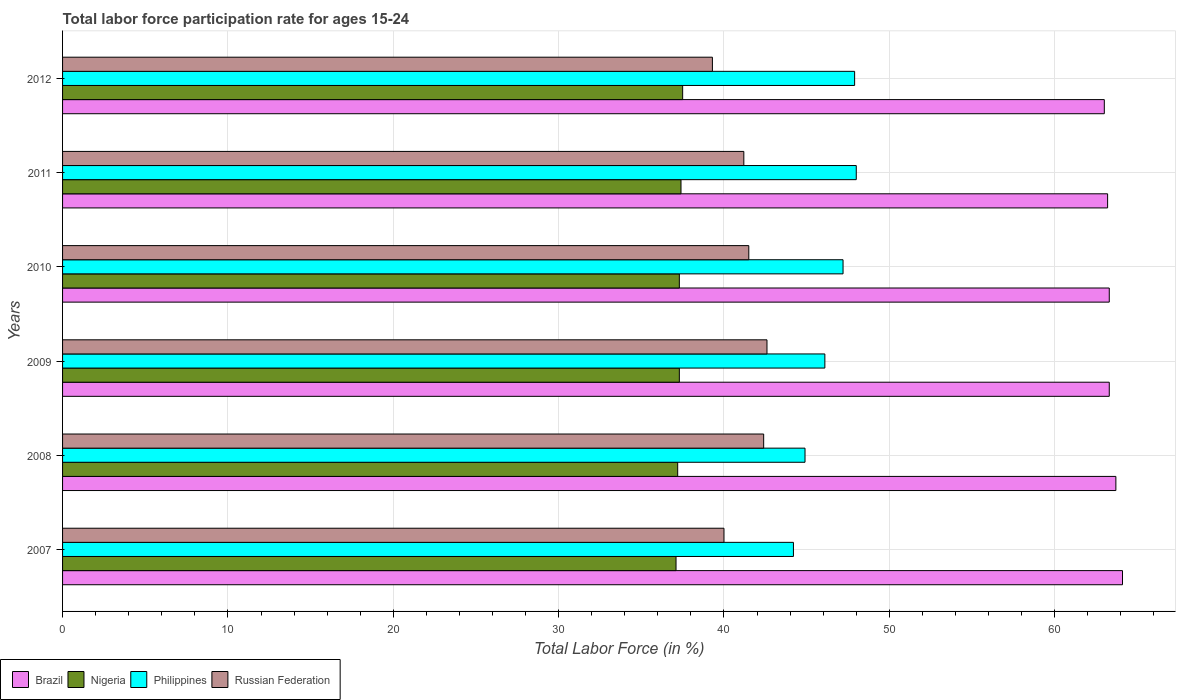How many different coloured bars are there?
Your answer should be compact. 4. How many groups of bars are there?
Your answer should be very brief. 6. Are the number of bars per tick equal to the number of legend labels?
Keep it short and to the point. Yes. Are the number of bars on each tick of the Y-axis equal?
Your response must be concise. Yes. What is the label of the 1st group of bars from the top?
Make the answer very short. 2012. In how many cases, is the number of bars for a given year not equal to the number of legend labels?
Make the answer very short. 0. What is the labor force participation rate in Philippines in 2012?
Provide a short and direct response. 47.9. Across all years, what is the maximum labor force participation rate in Russian Federation?
Your answer should be very brief. 42.6. Across all years, what is the minimum labor force participation rate in Philippines?
Make the answer very short. 44.2. In which year was the labor force participation rate in Russian Federation minimum?
Ensure brevity in your answer.  2012. What is the total labor force participation rate in Russian Federation in the graph?
Keep it short and to the point. 247. What is the difference between the labor force participation rate in Philippines in 2007 and that in 2008?
Keep it short and to the point. -0.7. What is the difference between the labor force participation rate in Philippines in 2009 and the labor force participation rate in Russian Federation in 2007?
Offer a very short reply. 6.1. What is the average labor force participation rate in Philippines per year?
Give a very brief answer. 46.38. In the year 2011, what is the difference between the labor force participation rate in Nigeria and labor force participation rate in Philippines?
Give a very brief answer. -10.6. What is the ratio of the labor force participation rate in Brazil in 2008 to that in 2011?
Keep it short and to the point. 1.01. What is the difference between the highest and the second highest labor force participation rate in Nigeria?
Your response must be concise. 0.1. What is the difference between the highest and the lowest labor force participation rate in Brazil?
Provide a succinct answer. 1.1. Is it the case that in every year, the sum of the labor force participation rate in Philippines and labor force participation rate in Russian Federation is greater than the sum of labor force participation rate in Nigeria and labor force participation rate in Brazil?
Provide a succinct answer. No. What does the 1st bar from the top in 2008 represents?
Keep it short and to the point. Russian Federation. What does the 2nd bar from the bottom in 2007 represents?
Offer a very short reply. Nigeria. How many bars are there?
Offer a very short reply. 24. How many years are there in the graph?
Keep it short and to the point. 6. How are the legend labels stacked?
Make the answer very short. Horizontal. What is the title of the graph?
Your answer should be very brief. Total labor force participation rate for ages 15-24. Does "St. Kitts and Nevis" appear as one of the legend labels in the graph?
Keep it short and to the point. No. What is the label or title of the Y-axis?
Provide a short and direct response. Years. What is the Total Labor Force (in %) in Brazil in 2007?
Provide a short and direct response. 64.1. What is the Total Labor Force (in %) in Nigeria in 2007?
Your answer should be compact. 37.1. What is the Total Labor Force (in %) in Philippines in 2007?
Provide a succinct answer. 44.2. What is the Total Labor Force (in %) in Russian Federation in 2007?
Make the answer very short. 40. What is the Total Labor Force (in %) of Brazil in 2008?
Your answer should be compact. 63.7. What is the Total Labor Force (in %) in Nigeria in 2008?
Make the answer very short. 37.2. What is the Total Labor Force (in %) of Philippines in 2008?
Offer a terse response. 44.9. What is the Total Labor Force (in %) of Russian Federation in 2008?
Your answer should be compact. 42.4. What is the Total Labor Force (in %) of Brazil in 2009?
Ensure brevity in your answer.  63.3. What is the Total Labor Force (in %) of Nigeria in 2009?
Offer a very short reply. 37.3. What is the Total Labor Force (in %) of Philippines in 2009?
Offer a very short reply. 46.1. What is the Total Labor Force (in %) in Russian Federation in 2009?
Ensure brevity in your answer.  42.6. What is the Total Labor Force (in %) of Brazil in 2010?
Your answer should be compact. 63.3. What is the Total Labor Force (in %) of Nigeria in 2010?
Offer a terse response. 37.3. What is the Total Labor Force (in %) in Philippines in 2010?
Your answer should be compact. 47.2. What is the Total Labor Force (in %) in Russian Federation in 2010?
Your response must be concise. 41.5. What is the Total Labor Force (in %) in Brazil in 2011?
Keep it short and to the point. 63.2. What is the Total Labor Force (in %) in Nigeria in 2011?
Offer a very short reply. 37.4. What is the Total Labor Force (in %) of Philippines in 2011?
Make the answer very short. 48. What is the Total Labor Force (in %) in Russian Federation in 2011?
Make the answer very short. 41.2. What is the Total Labor Force (in %) of Brazil in 2012?
Offer a terse response. 63. What is the Total Labor Force (in %) in Nigeria in 2012?
Offer a very short reply. 37.5. What is the Total Labor Force (in %) in Philippines in 2012?
Provide a succinct answer. 47.9. What is the Total Labor Force (in %) in Russian Federation in 2012?
Give a very brief answer. 39.3. Across all years, what is the maximum Total Labor Force (in %) of Brazil?
Keep it short and to the point. 64.1. Across all years, what is the maximum Total Labor Force (in %) of Nigeria?
Make the answer very short. 37.5. Across all years, what is the maximum Total Labor Force (in %) in Russian Federation?
Your response must be concise. 42.6. Across all years, what is the minimum Total Labor Force (in %) of Brazil?
Offer a terse response. 63. Across all years, what is the minimum Total Labor Force (in %) in Nigeria?
Give a very brief answer. 37.1. Across all years, what is the minimum Total Labor Force (in %) in Philippines?
Your answer should be compact. 44.2. Across all years, what is the minimum Total Labor Force (in %) of Russian Federation?
Make the answer very short. 39.3. What is the total Total Labor Force (in %) in Brazil in the graph?
Give a very brief answer. 380.6. What is the total Total Labor Force (in %) of Nigeria in the graph?
Your answer should be compact. 223.8. What is the total Total Labor Force (in %) in Philippines in the graph?
Offer a terse response. 278.3. What is the total Total Labor Force (in %) of Russian Federation in the graph?
Your response must be concise. 247. What is the difference between the Total Labor Force (in %) of Philippines in 2007 and that in 2008?
Your answer should be very brief. -0.7. What is the difference between the Total Labor Force (in %) of Brazil in 2007 and that in 2009?
Your response must be concise. 0.8. What is the difference between the Total Labor Force (in %) in Nigeria in 2007 and that in 2009?
Your answer should be compact. -0.2. What is the difference between the Total Labor Force (in %) of Philippines in 2007 and that in 2009?
Provide a succinct answer. -1.9. What is the difference between the Total Labor Force (in %) in Russian Federation in 2007 and that in 2009?
Your answer should be compact. -2.6. What is the difference between the Total Labor Force (in %) in Brazil in 2007 and that in 2011?
Offer a terse response. 0.9. What is the difference between the Total Labor Force (in %) of Philippines in 2007 and that in 2011?
Keep it short and to the point. -3.8. What is the difference between the Total Labor Force (in %) of Russian Federation in 2007 and that in 2011?
Provide a short and direct response. -1.2. What is the difference between the Total Labor Force (in %) of Russian Federation in 2007 and that in 2012?
Make the answer very short. 0.7. What is the difference between the Total Labor Force (in %) in Brazil in 2008 and that in 2009?
Provide a succinct answer. 0.4. What is the difference between the Total Labor Force (in %) of Nigeria in 2008 and that in 2009?
Provide a short and direct response. -0.1. What is the difference between the Total Labor Force (in %) in Philippines in 2008 and that in 2010?
Keep it short and to the point. -2.3. What is the difference between the Total Labor Force (in %) in Nigeria in 2008 and that in 2012?
Offer a very short reply. -0.3. What is the difference between the Total Labor Force (in %) of Brazil in 2009 and that in 2010?
Keep it short and to the point. 0. What is the difference between the Total Labor Force (in %) in Nigeria in 2009 and that in 2010?
Provide a succinct answer. 0. What is the difference between the Total Labor Force (in %) of Philippines in 2009 and that in 2010?
Make the answer very short. -1.1. What is the difference between the Total Labor Force (in %) of Brazil in 2009 and that in 2011?
Your response must be concise. 0.1. What is the difference between the Total Labor Force (in %) of Nigeria in 2009 and that in 2011?
Keep it short and to the point. -0.1. What is the difference between the Total Labor Force (in %) in Russian Federation in 2009 and that in 2011?
Provide a succinct answer. 1.4. What is the difference between the Total Labor Force (in %) in Nigeria in 2009 and that in 2012?
Offer a terse response. -0.2. What is the difference between the Total Labor Force (in %) of Nigeria in 2010 and that in 2011?
Keep it short and to the point. -0.1. What is the difference between the Total Labor Force (in %) in Russian Federation in 2010 and that in 2011?
Provide a short and direct response. 0.3. What is the difference between the Total Labor Force (in %) of Nigeria in 2010 and that in 2012?
Provide a succinct answer. -0.2. What is the difference between the Total Labor Force (in %) of Brazil in 2011 and that in 2012?
Provide a short and direct response. 0.2. What is the difference between the Total Labor Force (in %) in Brazil in 2007 and the Total Labor Force (in %) in Nigeria in 2008?
Your answer should be very brief. 26.9. What is the difference between the Total Labor Force (in %) of Brazil in 2007 and the Total Labor Force (in %) of Philippines in 2008?
Provide a short and direct response. 19.2. What is the difference between the Total Labor Force (in %) in Brazil in 2007 and the Total Labor Force (in %) in Russian Federation in 2008?
Ensure brevity in your answer.  21.7. What is the difference between the Total Labor Force (in %) of Nigeria in 2007 and the Total Labor Force (in %) of Russian Federation in 2008?
Your answer should be very brief. -5.3. What is the difference between the Total Labor Force (in %) of Philippines in 2007 and the Total Labor Force (in %) of Russian Federation in 2008?
Offer a terse response. 1.8. What is the difference between the Total Labor Force (in %) of Brazil in 2007 and the Total Labor Force (in %) of Nigeria in 2009?
Your response must be concise. 26.8. What is the difference between the Total Labor Force (in %) in Brazil in 2007 and the Total Labor Force (in %) in Philippines in 2009?
Your answer should be very brief. 18. What is the difference between the Total Labor Force (in %) of Brazil in 2007 and the Total Labor Force (in %) of Nigeria in 2010?
Your answer should be very brief. 26.8. What is the difference between the Total Labor Force (in %) in Brazil in 2007 and the Total Labor Force (in %) in Russian Federation in 2010?
Make the answer very short. 22.6. What is the difference between the Total Labor Force (in %) in Nigeria in 2007 and the Total Labor Force (in %) in Russian Federation in 2010?
Give a very brief answer. -4.4. What is the difference between the Total Labor Force (in %) in Brazil in 2007 and the Total Labor Force (in %) in Nigeria in 2011?
Give a very brief answer. 26.7. What is the difference between the Total Labor Force (in %) in Brazil in 2007 and the Total Labor Force (in %) in Russian Federation in 2011?
Your answer should be compact. 22.9. What is the difference between the Total Labor Force (in %) in Nigeria in 2007 and the Total Labor Force (in %) in Philippines in 2011?
Provide a short and direct response. -10.9. What is the difference between the Total Labor Force (in %) in Nigeria in 2007 and the Total Labor Force (in %) in Russian Federation in 2011?
Your answer should be very brief. -4.1. What is the difference between the Total Labor Force (in %) of Brazil in 2007 and the Total Labor Force (in %) of Nigeria in 2012?
Provide a succinct answer. 26.6. What is the difference between the Total Labor Force (in %) in Brazil in 2007 and the Total Labor Force (in %) in Russian Federation in 2012?
Offer a terse response. 24.8. What is the difference between the Total Labor Force (in %) in Nigeria in 2007 and the Total Labor Force (in %) in Philippines in 2012?
Your answer should be very brief. -10.8. What is the difference between the Total Labor Force (in %) of Philippines in 2007 and the Total Labor Force (in %) of Russian Federation in 2012?
Ensure brevity in your answer.  4.9. What is the difference between the Total Labor Force (in %) of Brazil in 2008 and the Total Labor Force (in %) of Nigeria in 2009?
Your response must be concise. 26.4. What is the difference between the Total Labor Force (in %) in Brazil in 2008 and the Total Labor Force (in %) in Philippines in 2009?
Make the answer very short. 17.6. What is the difference between the Total Labor Force (in %) of Brazil in 2008 and the Total Labor Force (in %) of Russian Federation in 2009?
Ensure brevity in your answer.  21.1. What is the difference between the Total Labor Force (in %) of Nigeria in 2008 and the Total Labor Force (in %) of Russian Federation in 2009?
Ensure brevity in your answer.  -5.4. What is the difference between the Total Labor Force (in %) of Philippines in 2008 and the Total Labor Force (in %) of Russian Federation in 2009?
Your response must be concise. 2.3. What is the difference between the Total Labor Force (in %) of Brazil in 2008 and the Total Labor Force (in %) of Nigeria in 2010?
Make the answer very short. 26.4. What is the difference between the Total Labor Force (in %) of Brazil in 2008 and the Total Labor Force (in %) of Philippines in 2010?
Ensure brevity in your answer.  16.5. What is the difference between the Total Labor Force (in %) in Brazil in 2008 and the Total Labor Force (in %) in Russian Federation in 2010?
Provide a short and direct response. 22.2. What is the difference between the Total Labor Force (in %) of Nigeria in 2008 and the Total Labor Force (in %) of Philippines in 2010?
Your response must be concise. -10. What is the difference between the Total Labor Force (in %) of Philippines in 2008 and the Total Labor Force (in %) of Russian Federation in 2010?
Give a very brief answer. 3.4. What is the difference between the Total Labor Force (in %) of Brazil in 2008 and the Total Labor Force (in %) of Nigeria in 2011?
Provide a succinct answer. 26.3. What is the difference between the Total Labor Force (in %) in Brazil in 2008 and the Total Labor Force (in %) in Philippines in 2011?
Give a very brief answer. 15.7. What is the difference between the Total Labor Force (in %) in Nigeria in 2008 and the Total Labor Force (in %) in Russian Federation in 2011?
Keep it short and to the point. -4. What is the difference between the Total Labor Force (in %) in Philippines in 2008 and the Total Labor Force (in %) in Russian Federation in 2011?
Keep it short and to the point. 3.7. What is the difference between the Total Labor Force (in %) of Brazil in 2008 and the Total Labor Force (in %) of Nigeria in 2012?
Give a very brief answer. 26.2. What is the difference between the Total Labor Force (in %) in Brazil in 2008 and the Total Labor Force (in %) in Philippines in 2012?
Keep it short and to the point. 15.8. What is the difference between the Total Labor Force (in %) in Brazil in 2008 and the Total Labor Force (in %) in Russian Federation in 2012?
Make the answer very short. 24.4. What is the difference between the Total Labor Force (in %) in Brazil in 2009 and the Total Labor Force (in %) in Nigeria in 2010?
Offer a terse response. 26. What is the difference between the Total Labor Force (in %) of Brazil in 2009 and the Total Labor Force (in %) of Russian Federation in 2010?
Give a very brief answer. 21.8. What is the difference between the Total Labor Force (in %) in Nigeria in 2009 and the Total Labor Force (in %) in Philippines in 2010?
Your answer should be compact. -9.9. What is the difference between the Total Labor Force (in %) in Nigeria in 2009 and the Total Labor Force (in %) in Russian Federation in 2010?
Make the answer very short. -4.2. What is the difference between the Total Labor Force (in %) of Philippines in 2009 and the Total Labor Force (in %) of Russian Federation in 2010?
Provide a short and direct response. 4.6. What is the difference between the Total Labor Force (in %) of Brazil in 2009 and the Total Labor Force (in %) of Nigeria in 2011?
Keep it short and to the point. 25.9. What is the difference between the Total Labor Force (in %) of Brazil in 2009 and the Total Labor Force (in %) of Philippines in 2011?
Your answer should be very brief. 15.3. What is the difference between the Total Labor Force (in %) of Brazil in 2009 and the Total Labor Force (in %) of Russian Federation in 2011?
Ensure brevity in your answer.  22.1. What is the difference between the Total Labor Force (in %) of Brazil in 2009 and the Total Labor Force (in %) of Nigeria in 2012?
Your response must be concise. 25.8. What is the difference between the Total Labor Force (in %) in Brazil in 2009 and the Total Labor Force (in %) in Russian Federation in 2012?
Your answer should be compact. 24. What is the difference between the Total Labor Force (in %) in Nigeria in 2009 and the Total Labor Force (in %) in Philippines in 2012?
Offer a terse response. -10.6. What is the difference between the Total Labor Force (in %) in Philippines in 2009 and the Total Labor Force (in %) in Russian Federation in 2012?
Your response must be concise. 6.8. What is the difference between the Total Labor Force (in %) of Brazil in 2010 and the Total Labor Force (in %) of Nigeria in 2011?
Your answer should be compact. 25.9. What is the difference between the Total Labor Force (in %) of Brazil in 2010 and the Total Labor Force (in %) of Philippines in 2011?
Your answer should be compact. 15.3. What is the difference between the Total Labor Force (in %) of Brazil in 2010 and the Total Labor Force (in %) of Russian Federation in 2011?
Ensure brevity in your answer.  22.1. What is the difference between the Total Labor Force (in %) of Nigeria in 2010 and the Total Labor Force (in %) of Philippines in 2011?
Give a very brief answer. -10.7. What is the difference between the Total Labor Force (in %) of Philippines in 2010 and the Total Labor Force (in %) of Russian Federation in 2011?
Offer a terse response. 6. What is the difference between the Total Labor Force (in %) in Brazil in 2010 and the Total Labor Force (in %) in Nigeria in 2012?
Your response must be concise. 25.8. What is the difference between the Total Labor Force (in %) in Brazil in 2010 and the Total Labor Force (in %) in Russian Federation in 2012?
Your answer should be compact. 24. What is the difference between the Total Labor Force (in %) of Nigeria in 2010 and the Total Labor Force (in %) of Philippines in 2012?
Keep it short and to the point. -10.6. What is the difference between the Total Labor Force (in %) in Nigeria in 2010 and the Total Labor Force (in %) in Russian Federation in 2012?
Provide a succinct answer. -2. What is the difference between the Total Labor Force (in %) in Philippines in 2010 and the Total Labor Force (in %) in Russian Federation in 2012?
Your answer should be very brief. 7.9. What is the difference between the Total Labor Force (in %) in Brazil in 2011 and the Total Labor Force (in %) in Nigeria in 2012?
Your answer should be very brief. 25.7. What is the difference between the Total Labor Force (in %) of Brazil in 2011 and the Total Labor Force (in %) of Russian Federation in 2012?
Offer a terse response. 23.9. What is the difference between the Total Labor Force (in %) of Nigeria in 2011 and the Total Labor Force (in %) of Russian Federation in 2012?
Provide a succinct answer. -1.9. What is the average Total Labor Force (in %) of Brazil per year?
Provide a succinct answer. 63.43. What is the average Total Labor Force (in %) of Nigeria per year?
Give a very brief answer. 37.3. What is the average Total Labor Force (in %) of Philippines per year?
Ensure brevity in your answer.  46.38. What is the average Total Labor Force (in %) in Russian Federation per year?
Your answer should be compact. 41.17. In the year 2007, what is the difference between the Total Labor Force (in %) in Brazil and Total Labor Force (in %) in Nigeria?
Your answer should be compact. 27. In the year 2007, what is the difference between the Total Labor Force (in %) of Brazil and Total Labor Force (in %) of Russian Federation?
Your response must be concise. 24.1. In the year 2007, what is the difference between the Total Labor Force (in %) of Nigeria and Total Labor Force (in %) of Russian Federation?
Your response must be concise. -2.9. In the year 2008, what is the difference between the Total Labor Force (in %) in Brazil and Total Labor Force (in %) in Nigeria?
Give a very brief answer. 26.5. In the year 2008, what is the difference between the Total Labor Force (in %) of Brazil and Total Labor Force (in %) of Russian Federation?
Provide a succinct answer. 21.3. In the year 2008, what is the difference between the Total Labor Force (in %) of Nigeria and Total Labor Force (in %) of Russian Federation?
Keep it short and to the point. -5.2. In the year 2009, what is the difference between the Total Labor Force (in %) in Brazil and Total Labor Force (in %) in Philippines?
Your answer should be very brief. 17.2. In the year 2009, what is the difference between the Total Labor Force (in %) of Brazil and Total Labor Force (in %) of Russian Federation?
Ensure brevity in your answer.  20.7. In the year 2009, what is the difference between the Total Labor Force (in %) of Philippines and Total Labor Force (in %) of Russian Federation?
Your answer should be compact. 3.5. In the year 2010, what is the difference between the Total Labor Force (in %) in Brazil and Total Labor Force (in %) in Russian Federation?
Make the answer very short. 21.8. In the year 2010, what is the difference between the Total Labor Force (in %) in Nigeria and Total Labor Force (in %) in Philippines?
Make the answer very short. -9.9. In the year 2010, what is the difference between the Total Labor Force (in %) in Nigeria and Total Labor Force (in %) in Russian Federation?
Offer a very short reply. -4.2. In the year 2010, what is the difference between the Total Labor Force (in %) of Philippines and Total Labor Force (in %) of Russian Federation?
Keep it short and to the point. 5.7. In the year 2011, what is the difference between the Total Labor Force (in %) in Brazil and Total Labor Force (in %) in Nigeria?
Offer a terse response. 25.8. In the year 2011, what is the difference between the Total Labor Force (in %) of Brazil and Total Labor Force (in %) of Philippines?
Your answer should be compact. 15.2. In the year 2011, what is the difference between the Total Labor Force (in %) of Nigeria and Total Labor Force (in %) of Philippines?
Your response must be concise. -10.6. In the year 2011, what is the difference between the Total Labor Force (in %) in Nigeria and Total Labor Force (in %) in Russian Federation?
Keep it short and to the point. -3.8. In the year 2012, what is the difference between the Total Labor Force (in %) in Brazil and Total Labor Force (in %) in Nigeria?
Offer a terse response. 25.5. In the year 2012, what is the difference between the Total Labor Force (in %) of Brazil and Total Labor Force (in %) of Philippines?
Make the answer very short. 15.1. In the year 2012, what is the difference between the Total Labor Force (in %) in Brazil and Total Labor Force (in %) in Russian Federation?
Your answer should be compact. 23.7. In the year 2012, what is the difference between the Total Labor Force (in %) of Nigeria and Total Labor Force (in %) of Russian Federation?
Ensure brevity in your answer.  -1.8. In the year 2012, what is the difference between the Total Labor Force (in %) in Philippines and Total Labor Force (in %) in Russian Federation?
Provide a short and direct response. 8.6. What is the ratio of the Total Labor Force (in %) of Brazil in 2007 to that in 2008?
Offer a terse response. 1.01. What is the ratio of the Total Labor Force (in %) of Nigeria in 2007 to that in 2008?
Ensure brevity in your answer.  1. What is the ratio of the Total Labor Force (in %) of Philippines in 2007 to that in 2008?
Your answer should be compact. 0.98. What is the ratio of the Total Labor Force (in %) of Russian Federation in 2007 to that in 2008?
Provide a succinct answer. 0.94. What is the ratio of the Total Labor Force (in %) of Brazil in 2007 to that in 2009?
Ensure brevity in your answer.  1.01. What is the ratio of the Total Labor Force (in %) of Nigeria in 2007 to that in 2009?
Your answer should be very brief. 0.99. What is the ratio of the Total Labor Force (in %) in Philippines in 2007 to that in 2009?
Your answer should be compact. 0.96. What is the ratio of the Total Labor Force (in %) of Russian Federation in 2007 to that in 2009?
Provide a short and direct response. 0.94. What is the ratio of the Total Labor Force (in %) in Brazil in 2007 to that in 2010?
Offer a terse response. 1.01. What is the ratio of the Total Labor Force (in %) of Philippines in 2007 to that in 2010?
Provide a short and direct response. 0.94. What is the ratio of the Total Labor Force (in %) in Russian Federation in 2007 to that in 2010?
Your answer should be compact. 0.96. What is the ratio of the Total Labor Force (in %) of Brazil in 2007 to that in 2011?
Your answer should be compact. 1.01. What is the ratio of the Total Labor Force (in %) of Philippines in 2007 to that in 2011?
Your answer should be very brief. 0.92. What is the ratio of the Total Labor Force (in %) in Russian Federation in 2007 to that in 2011?
Provide a succinct answer. 0.97. What is the ratio of the Total Labor Force (in %) of Brazil in 2007 to that in 2012?
Provide a short and direct response. 1.02. What is the ratio of the Total Labor Force (in %) of Nigeria in 2007 to that in 2012?
Provide a short and direct response. 0.99. What is the ratio of the Total Labor Force (in %) of Philippines in 2007 to that in 2012?
Your response must be concise. 0.92. What is the ratio of the Total Labor Force (in %) of Russian Federation in 2007 to that in 2012?
Provide a succinct answer. 1.02. What is the ratio of the Total Labor Force (in %) in Nigeria in 2008 to that in 2009?
Your response must be concise. 1. What is the ratio of the Total Labor Force (in %) of Brazil in 2008 to that in 2010?
Provide a short and direct response. 1.01. What is the ratio of the Total Labor Force (in %) of Philippines in 2008 to that in 2010?
Your answer should be very brief. 0.95. What is the ratio of the Total Labor Force (in %) in Russian Federation in 2008 to that in 2010?
Provide a short and direct response. 1.02. What is the ratio of the Total Labor Force (in %) in Brazil in 2008 to that in 2011?
Offer a very short reply. 1.01. What is the ratio of the Total Labor Force (in %) of Nigeria in 2008 to that in 2011?
Your answer should be very brief. 0.99. What is the ratio of the Total Labor Force (in %) of Philippines in 2008 to that in 2011?
Provide a short and direct response. 0.94. What is the ratio of the Total Labor Force (in %) of Russian Federation in 2008 to that in 2011?
Provide a succinct answer. 1.03. What is the ratio of the Total Labor Force (in %) in Brazil in 2008 to that in 2012?
Ensure brevity in your answer.  1.01. What is the ratio of the Total Labor Force (in %) of Nigeria in 2008 to that in 2012?
Provide a succinct answer. 0.99. What is the ratio of the Total Labor Force (in %) of Philippines in 2008 to that in 2012?
Ensure brevity in your answer.  0.94. What is the ratio of the Total Labor Force (in %) of Russian Federation in 2008 to that in 2012?
Provide a succinct answer. 1.08. What is the ratio of the Total Labor Force (in %) of Nigeria in 2009 to that in 2010?
Your answer should be compact. 1. What is the ratio of the Total Labor Force (in %) in Philippines in 2009 to that in 2010?
Provide a short and direct response. 0.98. What is the ratio of the Total Labor Force (in %) in Russian Federation in 2009 to that in 2010?
Your answer should be very brief. 1.03. What is the ratio of the Total Labor Force (in %) of Philippines in 2009 to that in 2011?
Your answer should be very brief. 0.96. What is the ratio of the Total Labor Force (in %) in Russian Federation in 2009 to that in 2011?
Provide a short and direct response. 1.03. What is the ratio of the Total Labor Force (in %) in Philippines in 2009 to that in 2012?
Ensure brevity in your answer.  0.96. What is the ratio of the Total Labor Force (in %) of Russian Federation in 2009 to that in 2012?
Ensure brevity in your answer.  1.08. What is the ratio of the Total Labor Force (in %) of Brazil in 2010 to that in 2011?
Provide a short and direct response. 1. What is the ratio of the Total Labor Force (in %) in Nigeria in 2010 to that in 2011?
Your response must be concise. 1. What is the ratio of the Total Labor Force (in %) in Philippines in 2010 to that in 2011?
Give a very brief answer. 0.98. What is the ratio of the Total Labor Force (in %) in Russian Federation in 2010 to that in 2011?
Provide a succinct answer. 1.01. What is the ratio of the Total Labor Force (in %) in Philippines in 2010 to that in 2012?
Provide a short and direct response. 0.99. What is the ratio of the Total Labor Force (in %) of Russian Federation in 2010 to that in 2012?
Your answer should be very brief. 1.06. What is the ratio of the Total Labor Force (in %) of Philippines in 2011 to that in 2012?
Keep it short and to the point. 1. What is the ratio of the Total Labor Force (in %) of Russian Federation in 2011 to that in 2012?
Your answer should be compact. 1.05. What is the difference between the highest and the second highest Total Labor Force (in %) of Nigeria?
Your answer should be very brief. 0.1. What is the difference between the highest and the lowest Total Labor Force (in %) in Nigeria?
Your answer should be very brief. 0.4. What is the difference between the highest and the lowest Total Labor Force (in %) in Philippines?
Provide a succinct answer. 3.8. 